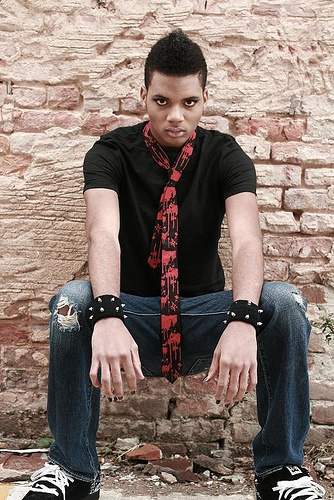Describe the objects in this image and their specific colors. I can see people in gray, black, pink, lightgray, and brown tones and tie in gray, black, maroon, brown, and salmon tones in this image. 